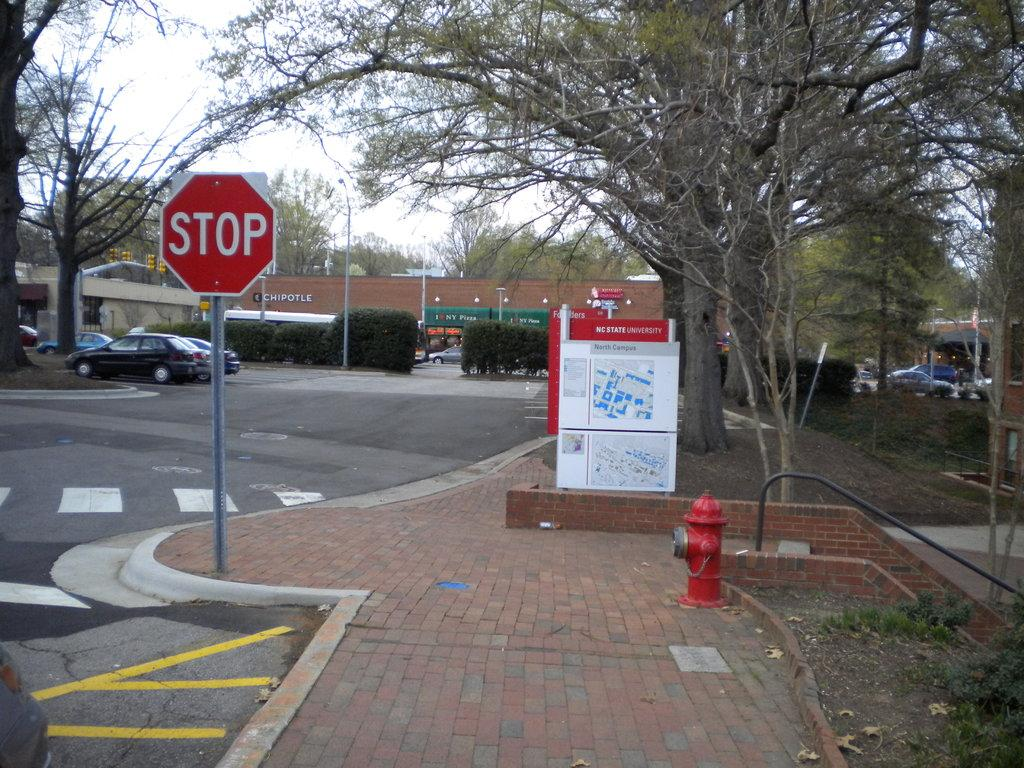Provide a one-sentence caption for the provided image. A stop sign next to a brick sidewalk in front of a NC State University North Campus map. 